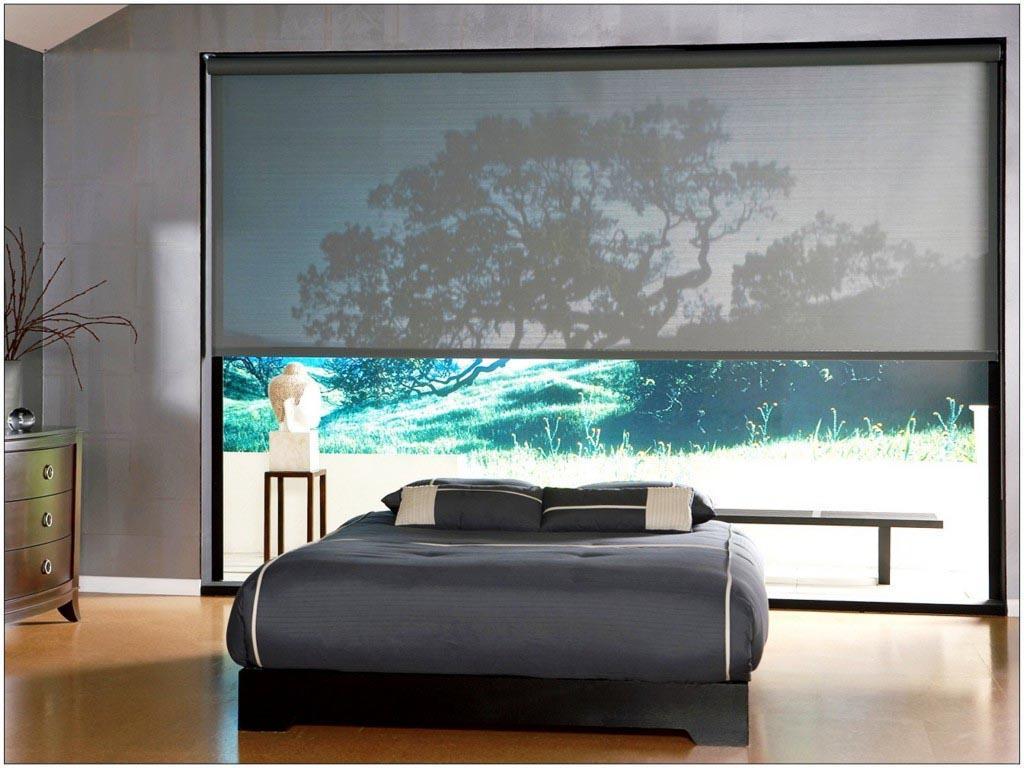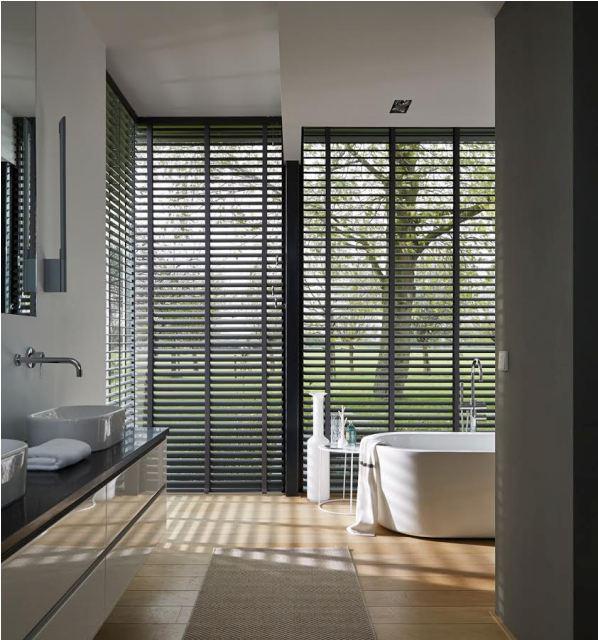The first image is the image on the left, the second image is the image on the right. Considering the images on both sides, is "There are no less than five blinds." valid? Answer yes or no. No. The first image is the image on the left, the second image is the image on the right. Examine the images to the left and right. Is the description "There is a bed in front of a nature backdrop." accurate? Answer yes or no. Yes. 